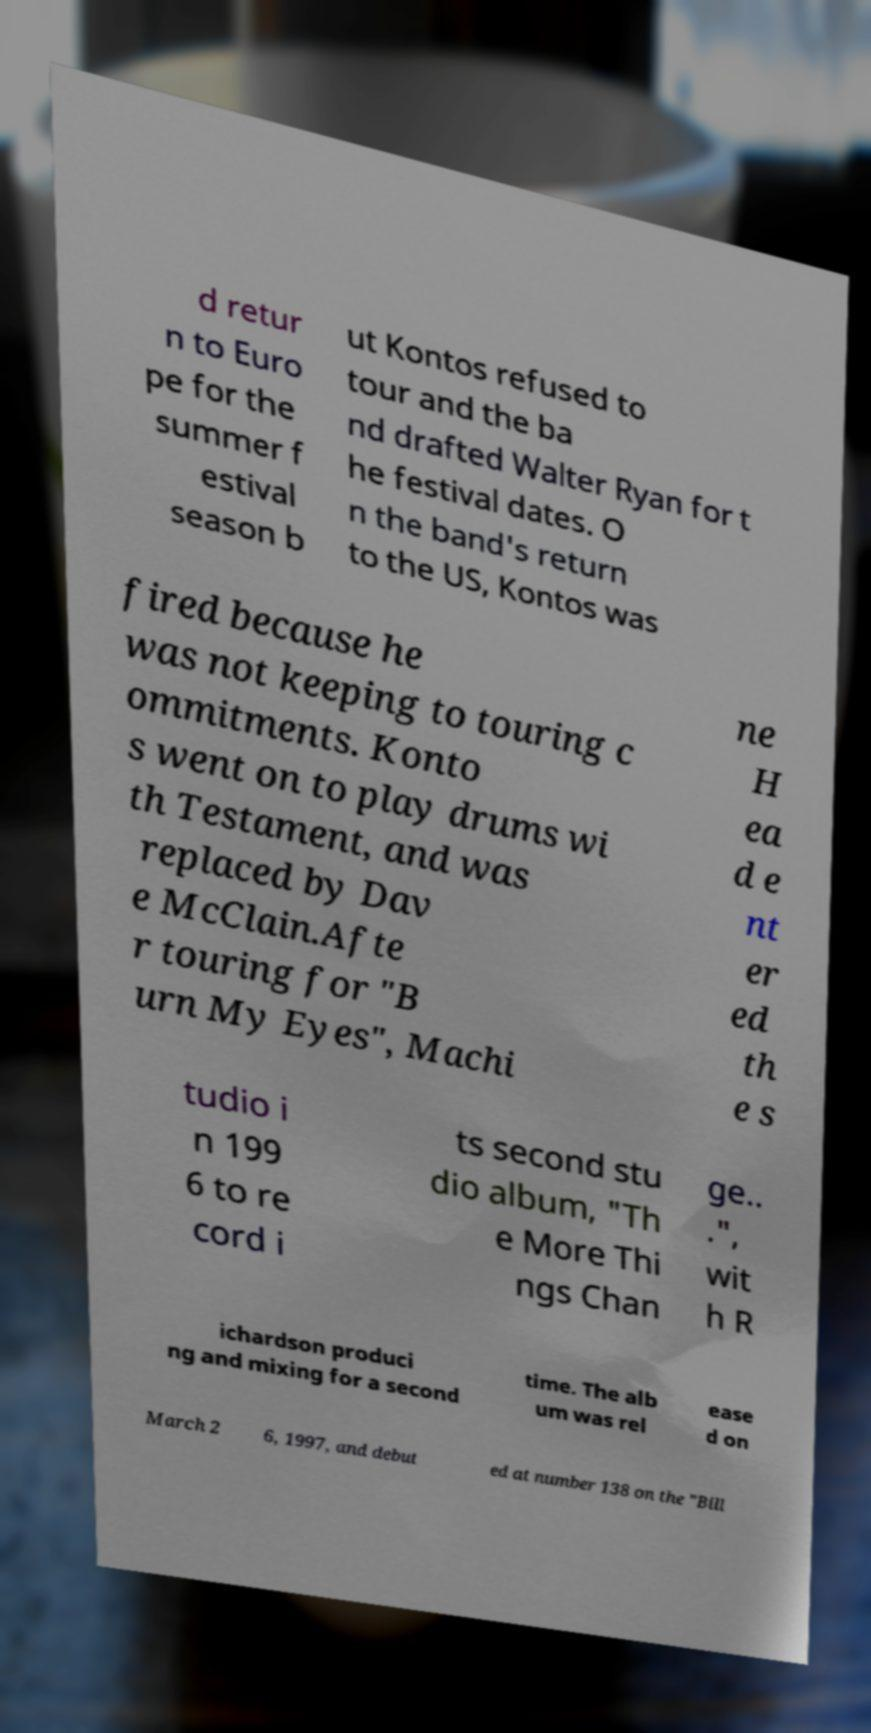Could you extract and type out the text from this image? d retur n to Euro pe for the summer f estival season b ut Kontos refused to tour and the ba nd drafted Walter Ryan for t he festival dates. O n the band's return to the US, Kontos was fired because he was not keeping to touring c ommitments. Konto s went on to play drums wi th Testament, and was replaced by Dav e McClain.Afte r touring for "B urn My Eyes", Machi ne H ea d e nt er ed th e s tudio i n 199 6 to re cord i ts second stu dio album, "Th e More Thi ngs Chan ge.. .", wit h R ichardson produci ng and mixing for a second time. The alb um was rel ease d on March 2 6, 1997, and debut ed at number 138 on the "Bill 